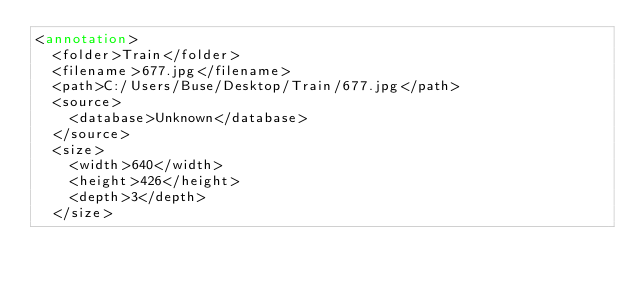Convert code to text. <code><loc_0><loc_0><loc_500><loc_500><_XML_><annotation>
	<folder>Train</folder>
	<filename>677.jpg</filename>
	<path>C:/Users/Buse/Desktop/Train/677.jpg</path>
	<source>
		<database>Unknown</database>
	</source>
	<size>
		<width>640</width>
		<height>426</height>
		<depth>3</depth>
	</size></code> 